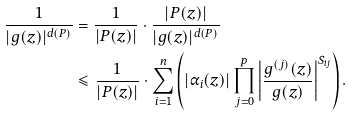<formula> <loc_0><loc_0><loc_500><loc_500>\frac { 1 } { | g ( z ) | ^ { d ( P ) } } & = \frac { 1 } { | P ( z ) | } \cdot \frac { | P ( z ) | } { | g ( z ) | ^ { d ( P ) } } \\ & \leqslant \frac { 1 } { | P ( z ) | } \cdot \sum _ { i = 1 } ^ { n } \left ( | \alpha _ { i } ( z ) | \prod _ { j = 0 } ^ { p } \left | \frac { g ^ { ( j ) } ( z ) } { g ( z ) } \right | ^ { S _ { i j } } \right ) .</formula> 